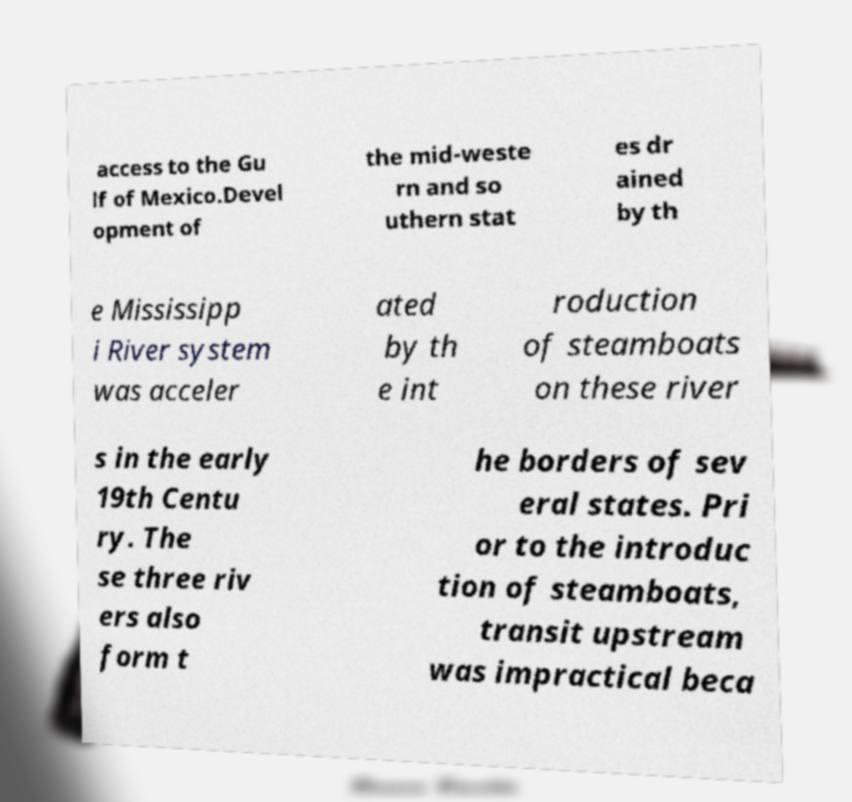Could you extract and type out the text from this image? access to the Gu lf of Mexico.Devel opment of the mid-weste rn and so uthern stat es dr ained by th e Mississipp i River system was acceler ated by th e int roduction of steamboats on these river s in the early 19th Centu ry. The se three riv ers also form t he borders of sev eral states. Pri or to the introduc tion of steamboats, transit upstream was impractical beca 